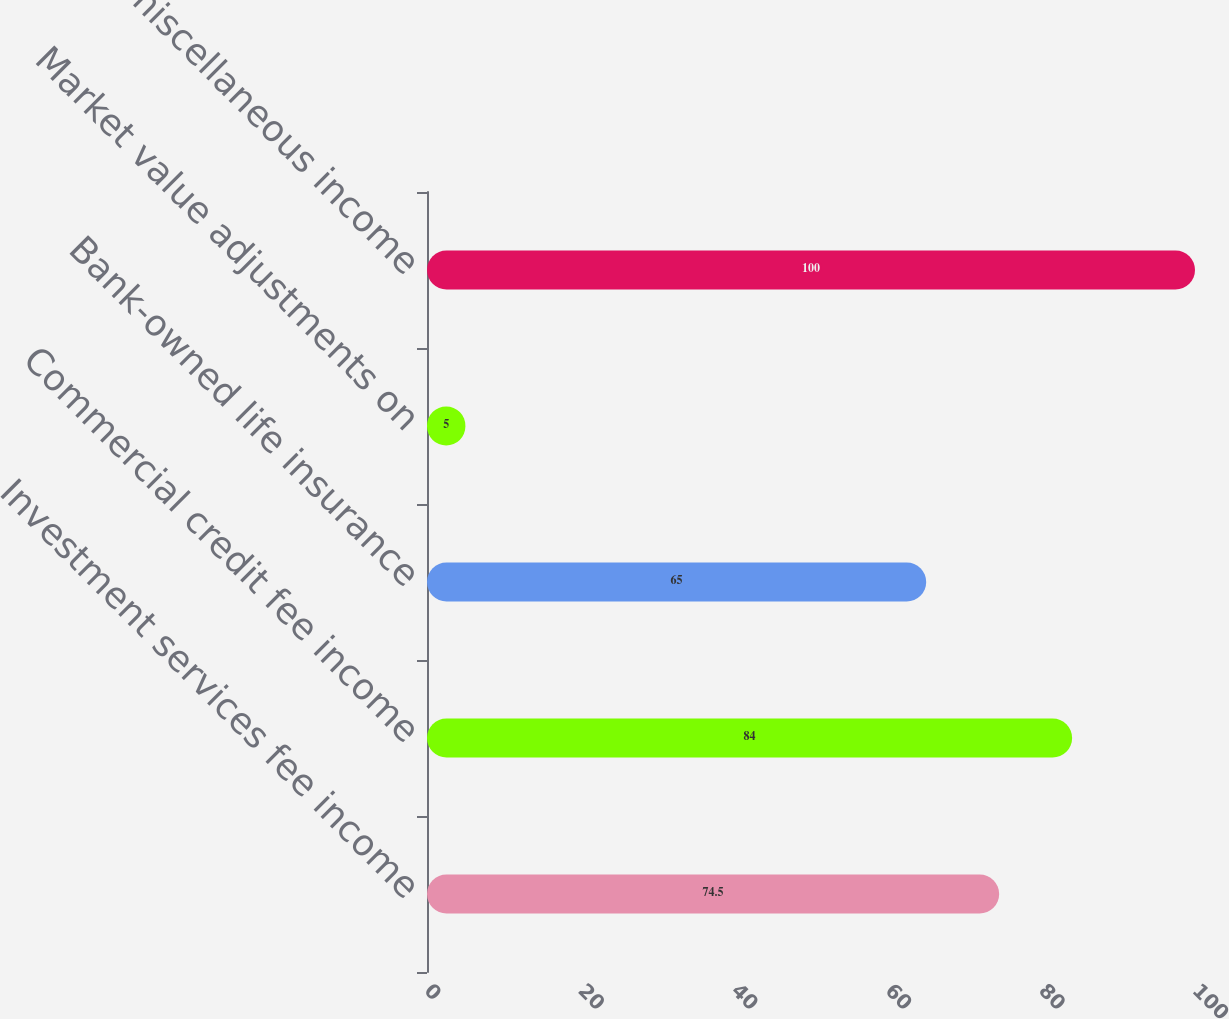Convert chart. <chart><loc_0><loc_0><loc_500><loc_500><bar_chart><fcel>Investment services fee income<fcel>Commercial credit fee income<fcel>Bank-owned life insurance<fcel>Market value adjustments on<fcel>Other miscellaneous income<nl><fcel>74.5<fcel>84<fcel>65<fcel>5<fcel>100<nl></chart> 